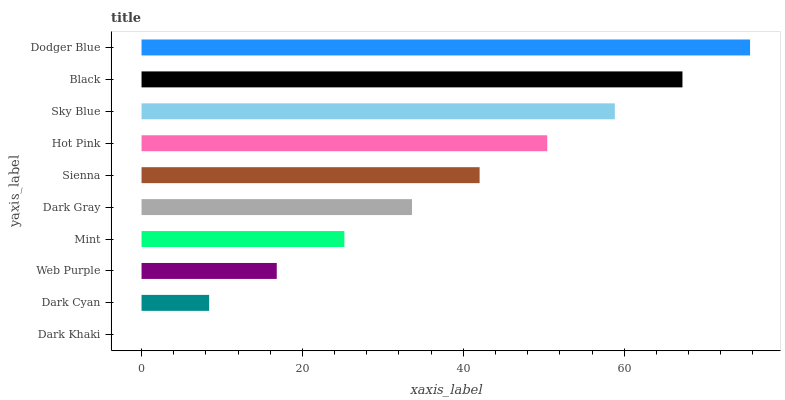Is Dark Khaki the minimum?
Answer yes or no. Yes. Is Dodger Blue the maximum?
Answer yes or no. Yes. Is Dark Cyan the minimum?
Answer yes or no. No. Is Dark Cyan the maximum?
Answer yes or no. No. Is Dark Cyan greater than Dark Khaki?
Answer yes or no. Yes. Is Dark Khaki less than Dark Cyan?
Answer yes or no. Yes. Is Dark Khaki greater than Dark Cyan?
Answer yes or no. No. Is Dark Cyan less than Dark Khaki?
Answer yes or no. No. Is Sienna the high median?
Answer yes or no. Yes. Is Dark Gray the low median?
Answer yes or no. Yes. Is Black the high median?
Answer yes or no. No. Is Dark Cyan the low median?
Answer yes or no. No. 